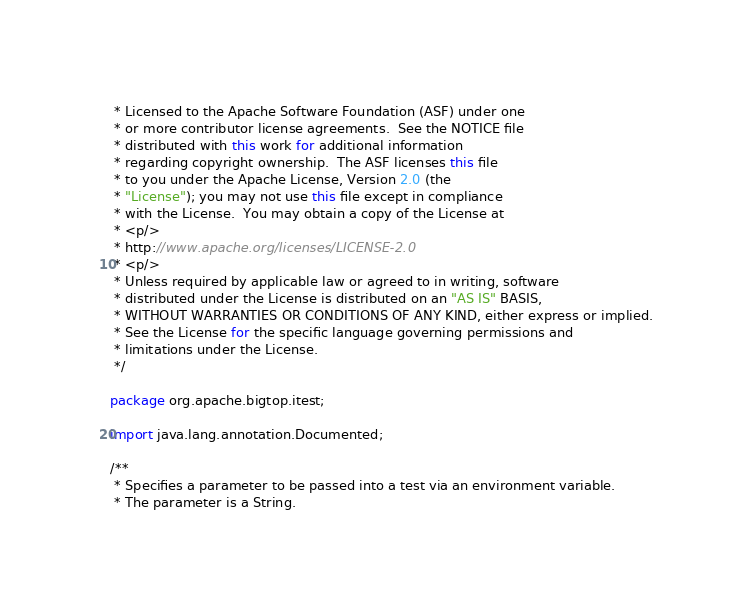<code> <loc_0><loc_0><loc_500><loc_500><_Java_> * Licensed to the Apache Software Foundation (ASF) under one
 * or more contributor license agreements.  See the NOTICE file
 * distributed with this work for additional information
 * regarding copyright ownership.  The ASF licenses this file
 * to you under the Apache License, Version 2.0 (the
 * "License"); you may not use this file except in compliance
 * with the License.  You may obtain a copy of the License at
 * <p/>
 * http://www.apache.org/licenses/LICENSE-2.0
 * <p/>
 * Unless required by applicable law or agreed to in writing, software
 * distributed under the License is distributed on an "AS IS" BASIS,
 * WITHOUT WARRANTIES OR CONDITIONS OF ANY KIND, either express or implied.
 * See the License for the specific language governing permissions and
 * limitations under the License.
 */

package org.apache.bigtop.itest;

import java.lang.annotation.Documented;

/**
 * Specifies a parameter to be passed into a test via an environment variable.
 * The parameter is a String.</code> 